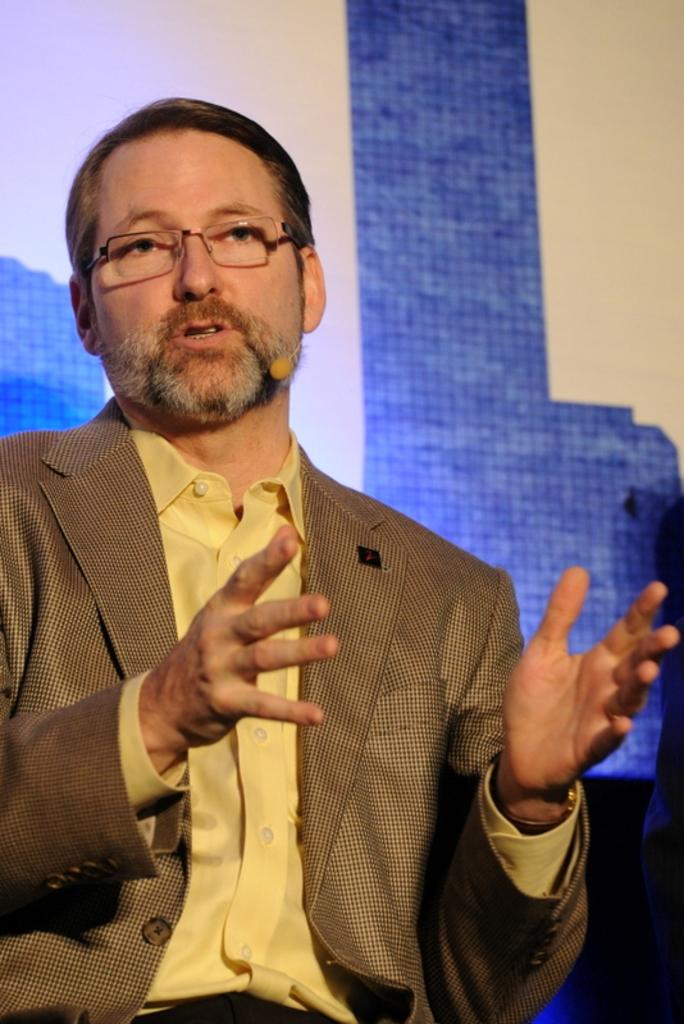What is the person in the image wearing on their face? The person is wearing spectacles. What is the person holding or wearing that is related to communication? The person is wearing a mic. What is the person doing in the image? The person is talking. Can you describe the background of the image? There is a blue and white wall in the background. What type of disease can be seen spreading in the image? There is no disease present in the image; it features a person talking while wearing a mic and spectacles in front of a blue and white wall. Can you tell me how many ovens are visible in the image? There are no ovens present in the image. 